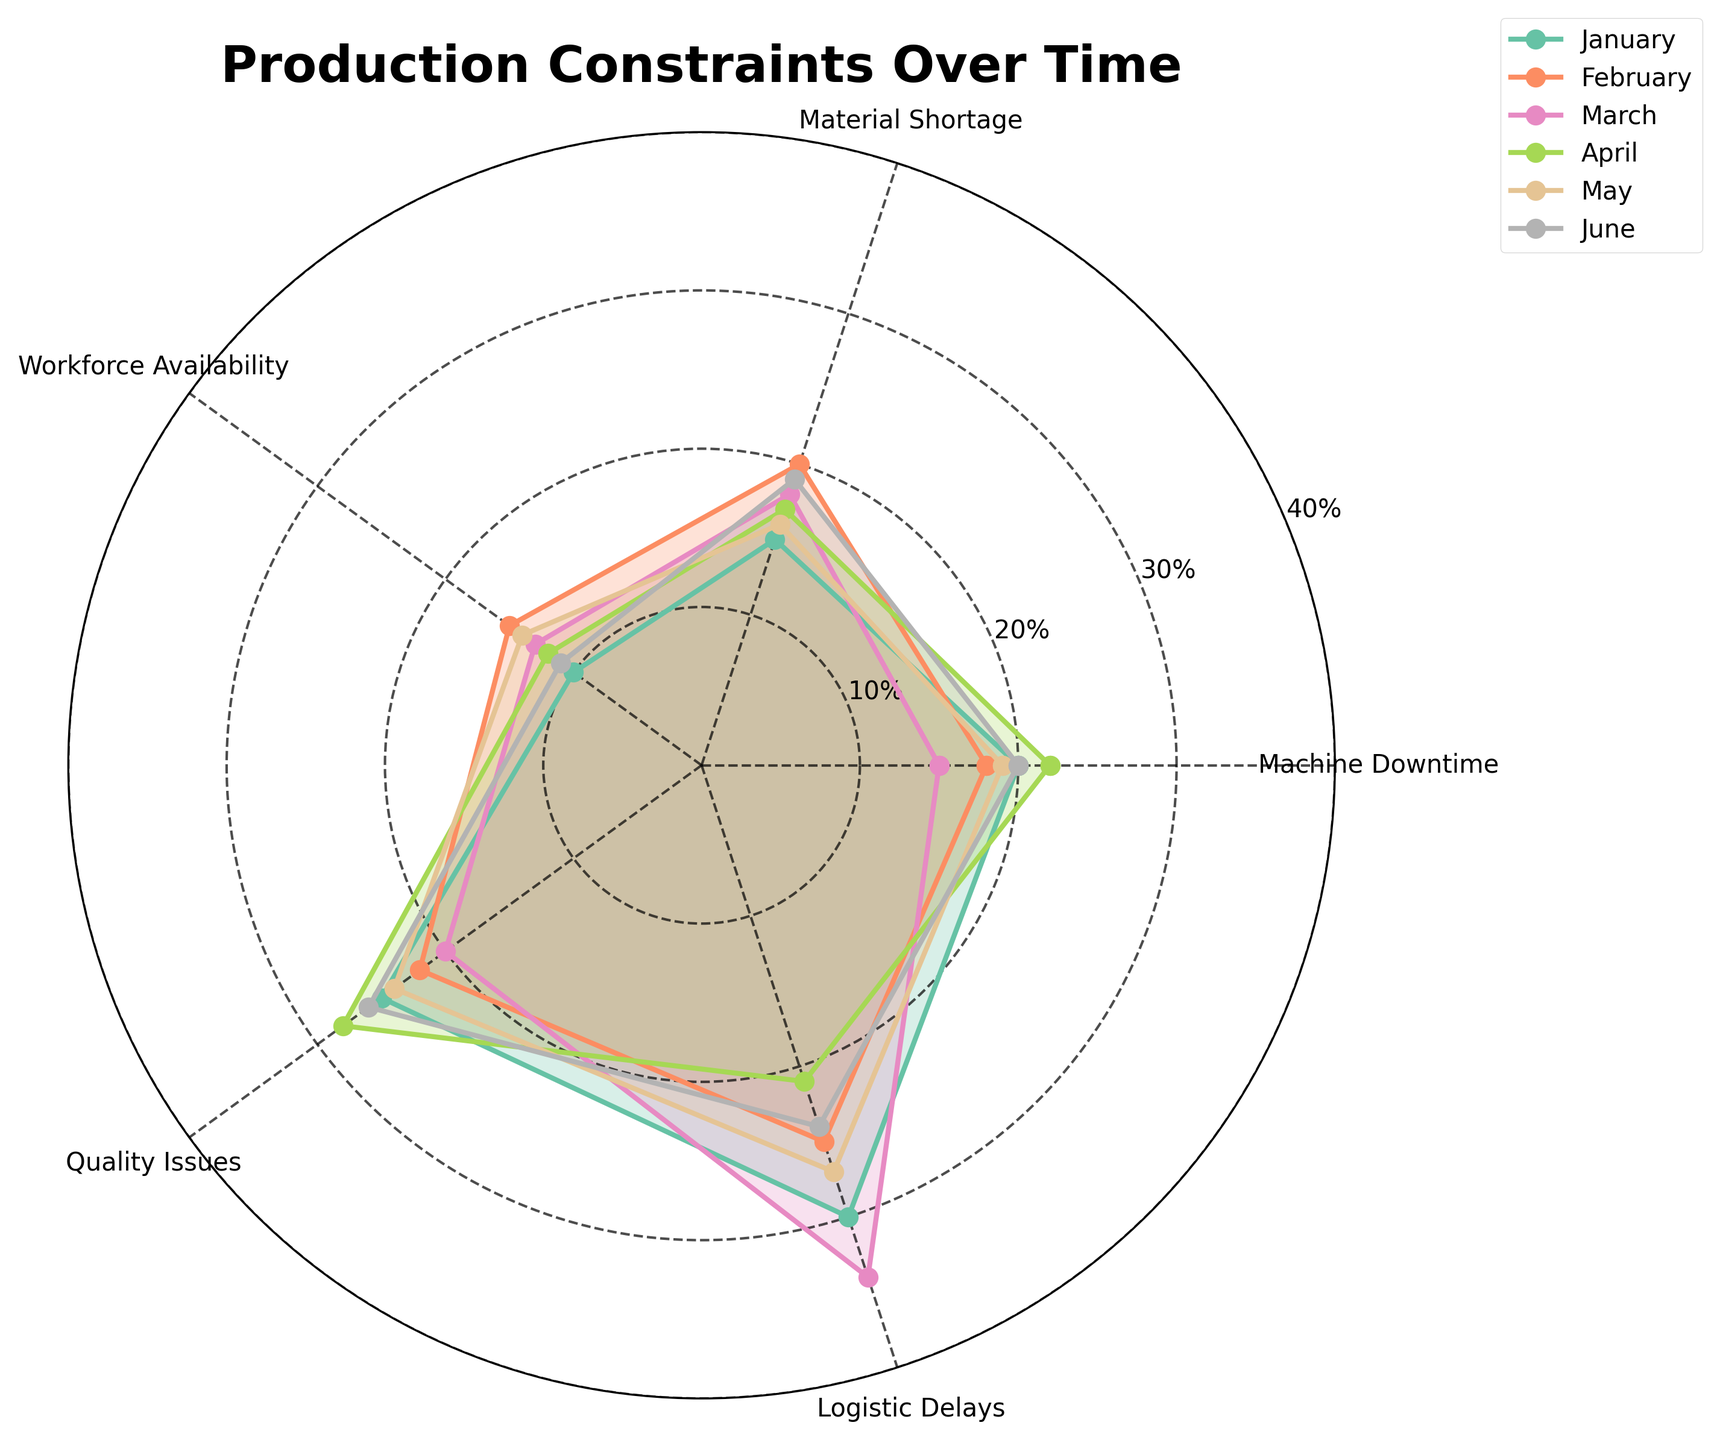What is the title of the radar chart? The title is usually located at the top of the chart and clearly indicates the subject of the visual representation.
Answer: Production Constraints Over Time Which month has the highest percentage contribution to logistic delays? Identify the highest point on the logistic delays axis for each month and compare them. The highest point indicates the month with the greatest contribution.
Answer: March In January, what percentage of production constraints is due to workforce availability? Locate the January plot on the radar chart and follow the line corresponding to workforce availability.
Answer: 10% Which constraint category had the most consistent values across all months? Observe the spread of values for each constraint category across all months. The constraint with the least variability in the radar chart is the most consistent.
Answer: Workforce Availability Did the percentage contribution to quality issues increase or decrease from January to April? Compare the values for January and April in the quality issues category on the radar chart.
Answer: Increase What is the average percentage contribution to material shortage across all months? Calculate the average by summing the material shortage values for all months and dividing by the number of months (15+20+18+17+16+19)/6.
Answer: 17.5% Which month had the overall lowest contribution across all constraints? Sum the percentage contributions for each month and identify the month with the lowest total.
Answer: March How does the machine downtime contribution in June compare to January? Compare the values for machine downtime in January and June on the radar chart to determine if it is higher, lower, or equal.
Answer: Same Which month exhibits the highest variability in constraints? Evaluate the spread of values for each month. The month with the widest range of values across different constraints has the highest variability.
Answer: March In which constraint did May have the highest percentage contribution compared to other constraints? Examine May's values across all constraints, identify the highest value which indicates its highest percentage contribution.
Answer: Logistic Delays 